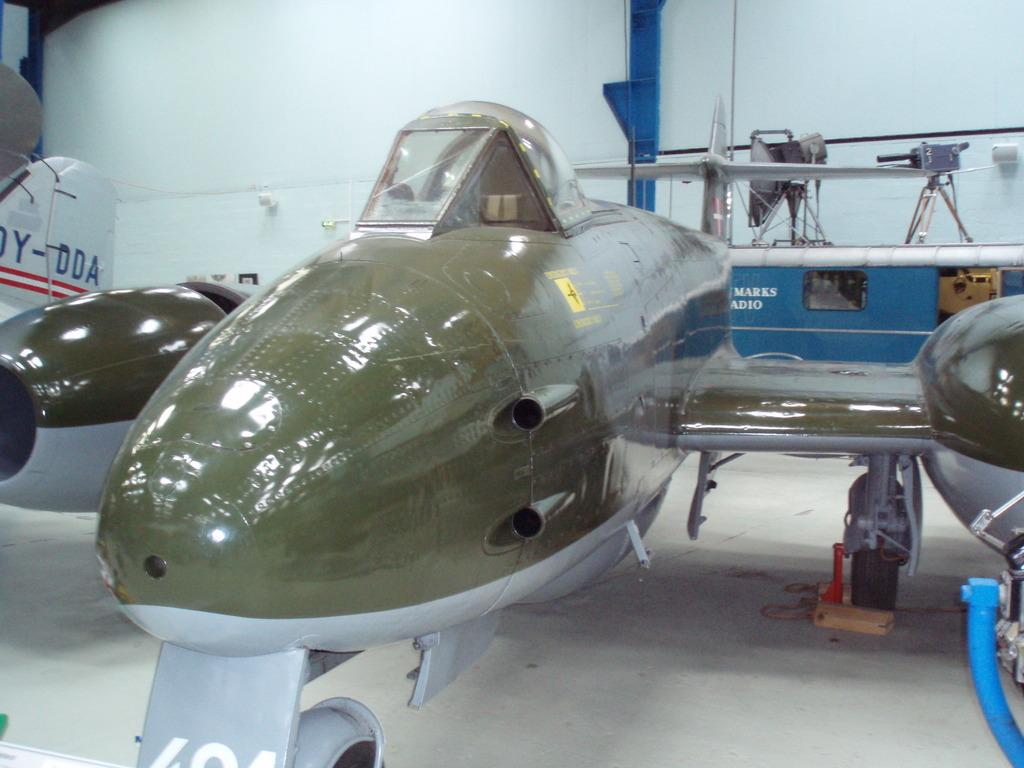Provide a one-sentence caption for the provided image. Old war planes sit on display with markings such as Marks Adio written on them. 